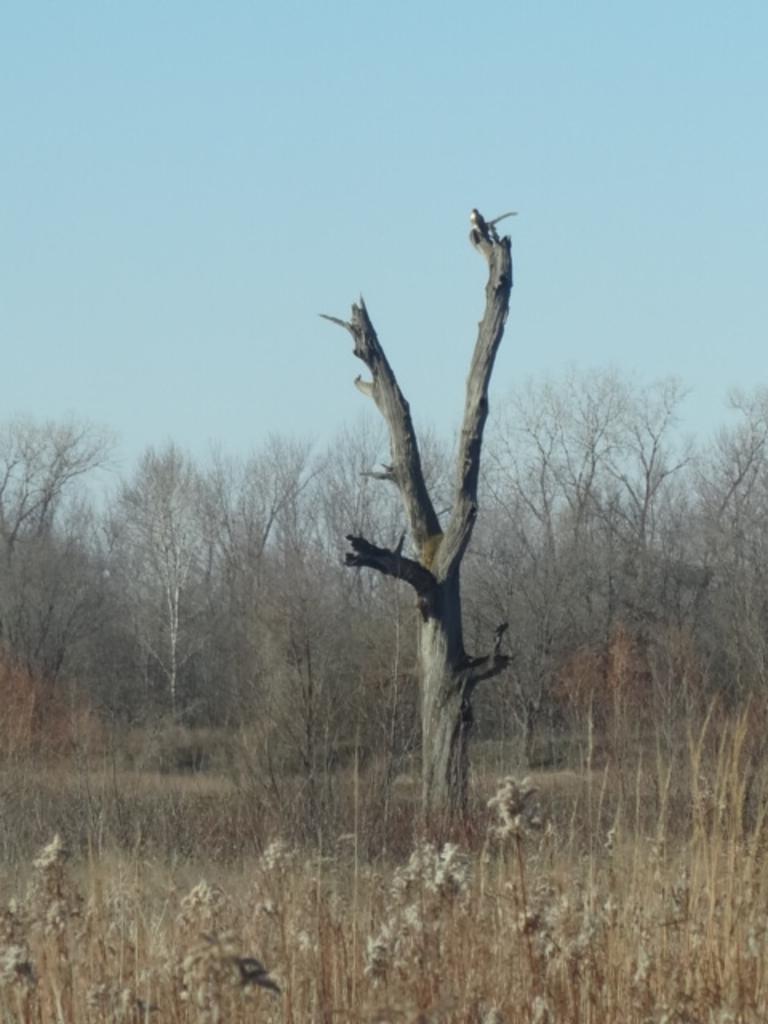How would you summarize this image in a sentence or two? In the foreground of the picture there are plants. In the center of the picture we can see the trunk of a tree. In the background there are trees and plants. At the top it is sky. 